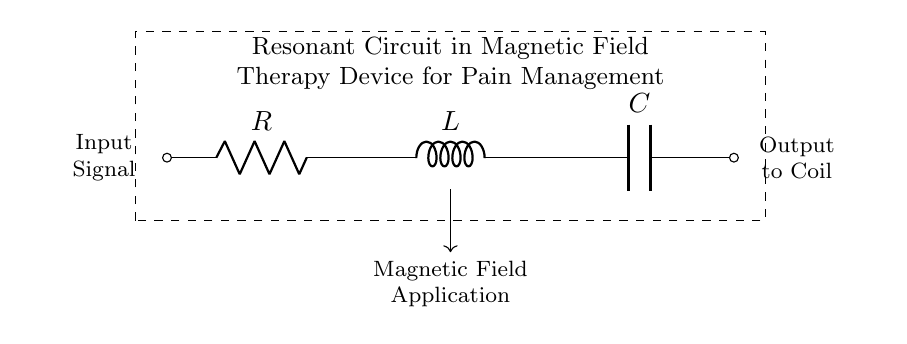What are the components of this circuit? The circuit contains three main components: a resistor, an inductor, and a capacitor. These are represented by "R", "L", and "C" respectively in the diagram.
Answer: resistor, inductor, capacitor What is the function of the inductor in this circuit? The inductor in this resonant circuit is used to store energy in a magnetic field when current flows through it, which contributes to resonant effects in the circuit.
Answer: store energy What is the output of this circuit connected to? The output of this circuit is connected to a coil, which typically generates a magnetic field for therapy applications based on the resonant frequency of the circuit.
Answer: coil Is this circuit in series or parallel configuration? The resistor, inductor, and capacitor are connected in series in this circuit, as they are arranged end-to-end without branching paths.
Answer: series What type of therapy is this circuit designed for? This resonant circuit is designed for magnetic field therapy applications specifically for pain management purposes, as indicated in the description within the diagram.
Answer: pain management At what point does the input signal enter the circuit? The input signal enters the circuit at the leftmost terminal, where it is connected to the resistor, thereby starting the current flow through the series configuration.
Answer: leftmost terminal What is the purpose of resonance in this circuit? The purpose of resonance in this circuit is to enhance the effectiveness of the treatment by achieving a frequency at which the inductive and capacitive reactances cancel each other, maximizing current flow and optimally applying the magnetic field.
Answer: enhance effectiveness 